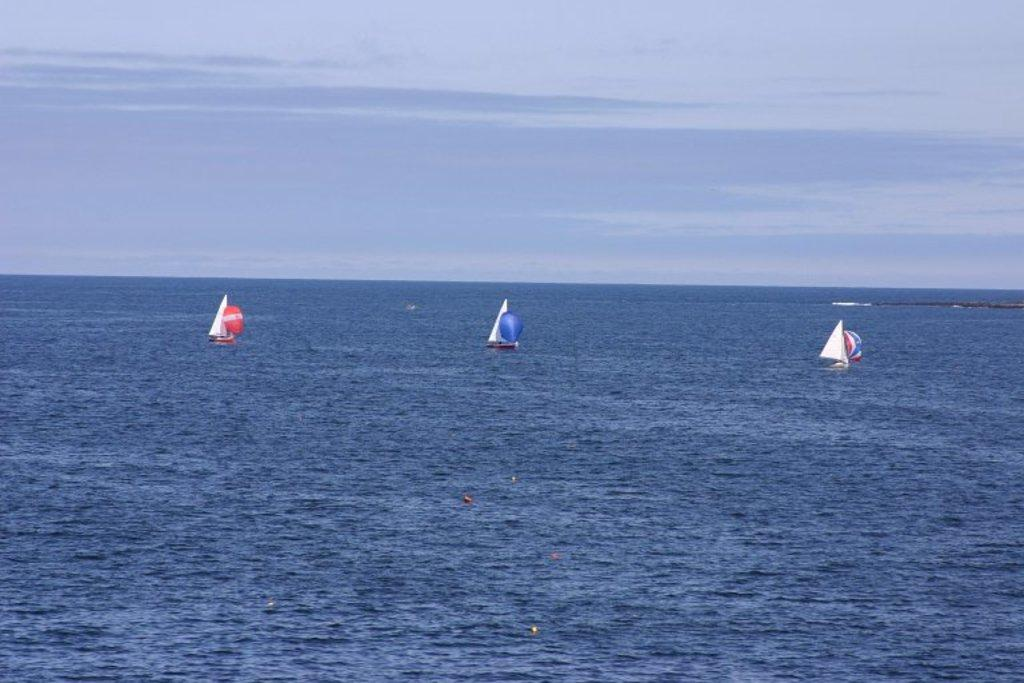What type of vehicles are in the water in the image? There are boats in the water in the image. What is the color and condition of the sky in the image? The sky is blue and cloudy in the image. What type of honey is being harvested by the farmer in the image? There is no farmer or honey present in the image; it features boats in the water and a blue, cloudy sky. 